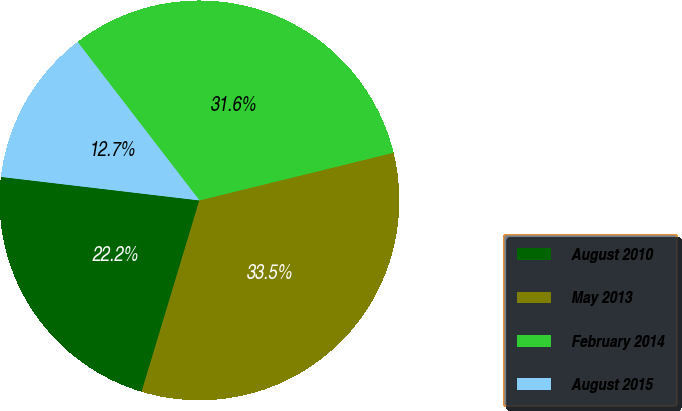<chart> <loc_0><loc_0><loc_500><loc_500><pie_chart><fcel>August 2010<fcel>May 2013<fcel>February 2014<fcel>August 2015<nl><fcel>22.21%<fcel>33.5%<fcel>31.6%<fcel>12.69%<nl></chart> 